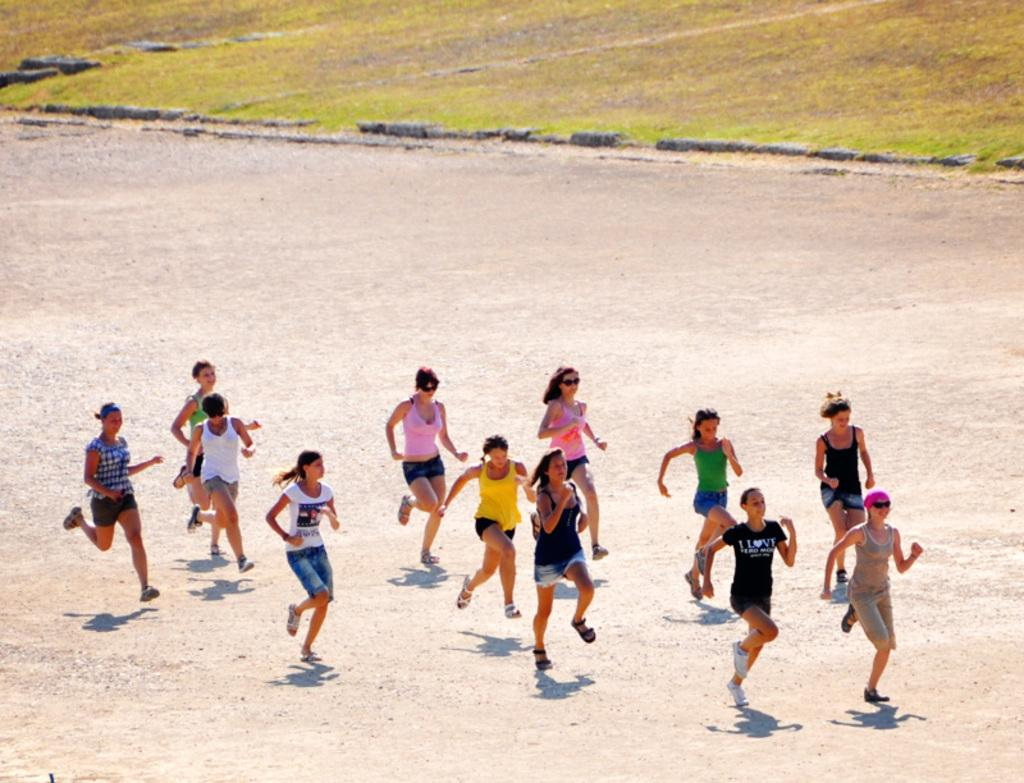What are the people in the image doing? The people in the image are running on the road. What can be seen in the background of the image? There is grass visible in the background of the image. What color is the spade being used by the person running in the image? There is no spade present in the image, and the people running are not using any tools. 